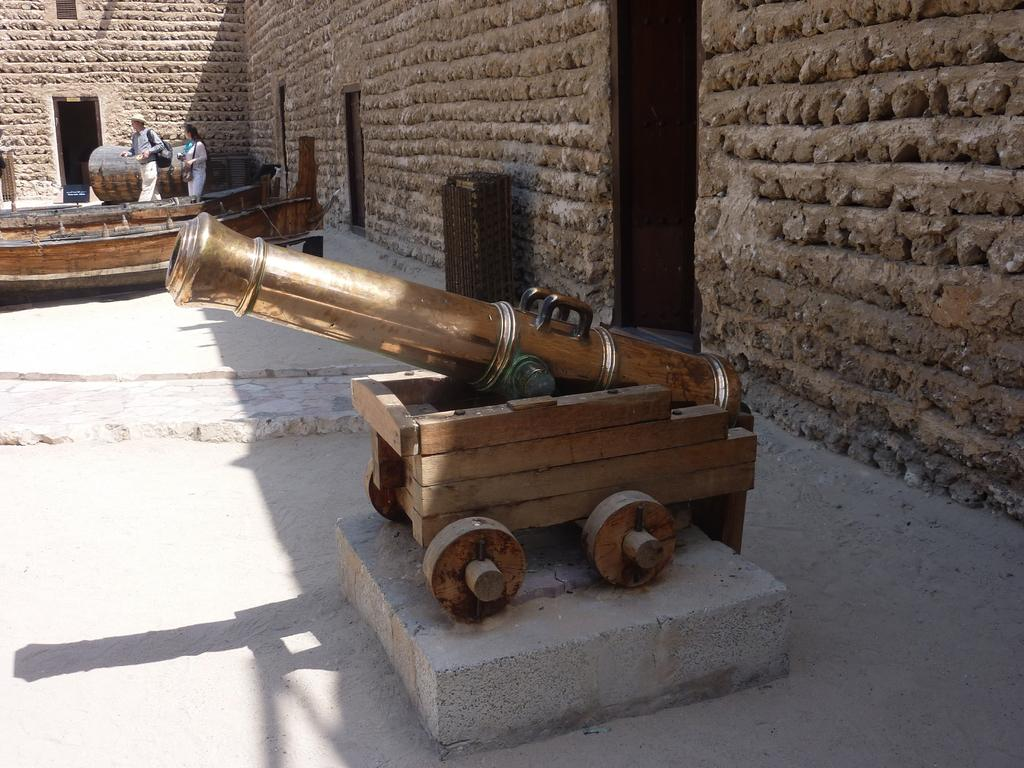What type of object can be seen in the image that might be used for protection or defense? There is a weapon in the image. What type of structures are visible in the image? There are walls and doors in the image. What material are some of the objects made of in the image? There are wooden objects in the image. How many people are present in the image? There are two persons in the image. What type of cheese is being discussed by the two persons in the image? There is no cheese present in the image, nor is there any indication of a conversation about cheese. 